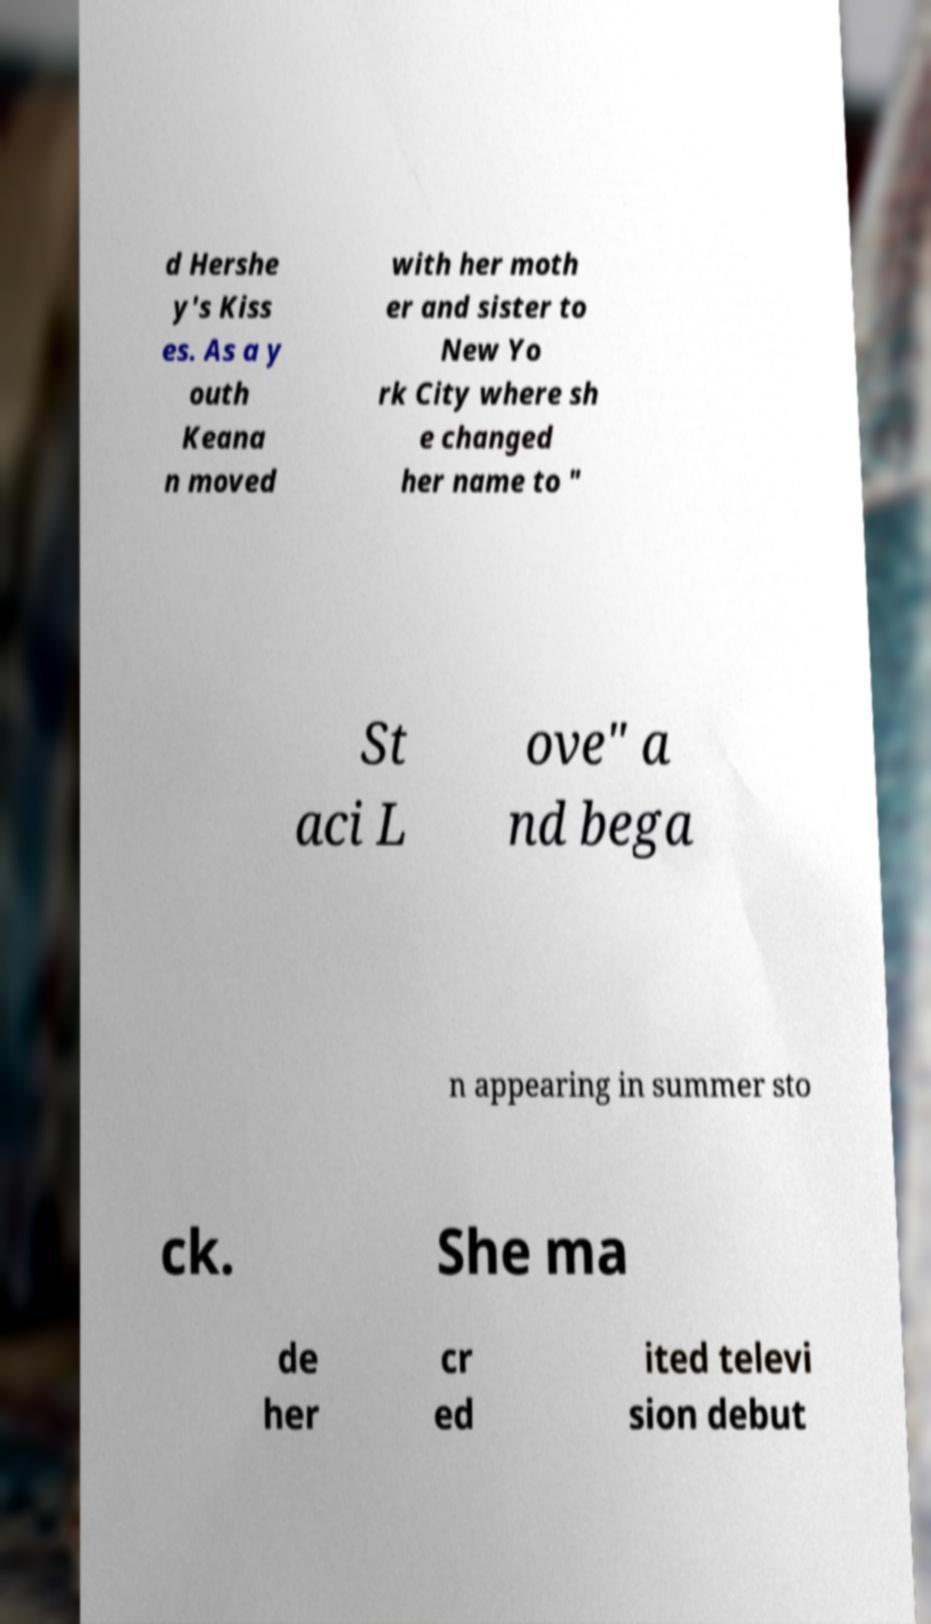Please identify and transcribe the text found in this image. d Hershe y's Kiss es. As a y outh Keana n moved with her moth er and sister to New Yo rk City where sh e changed her name to " St aci L ove" a nd bega n appearing in summer sto ck. She ma de her cr ed ited televi sion debut 